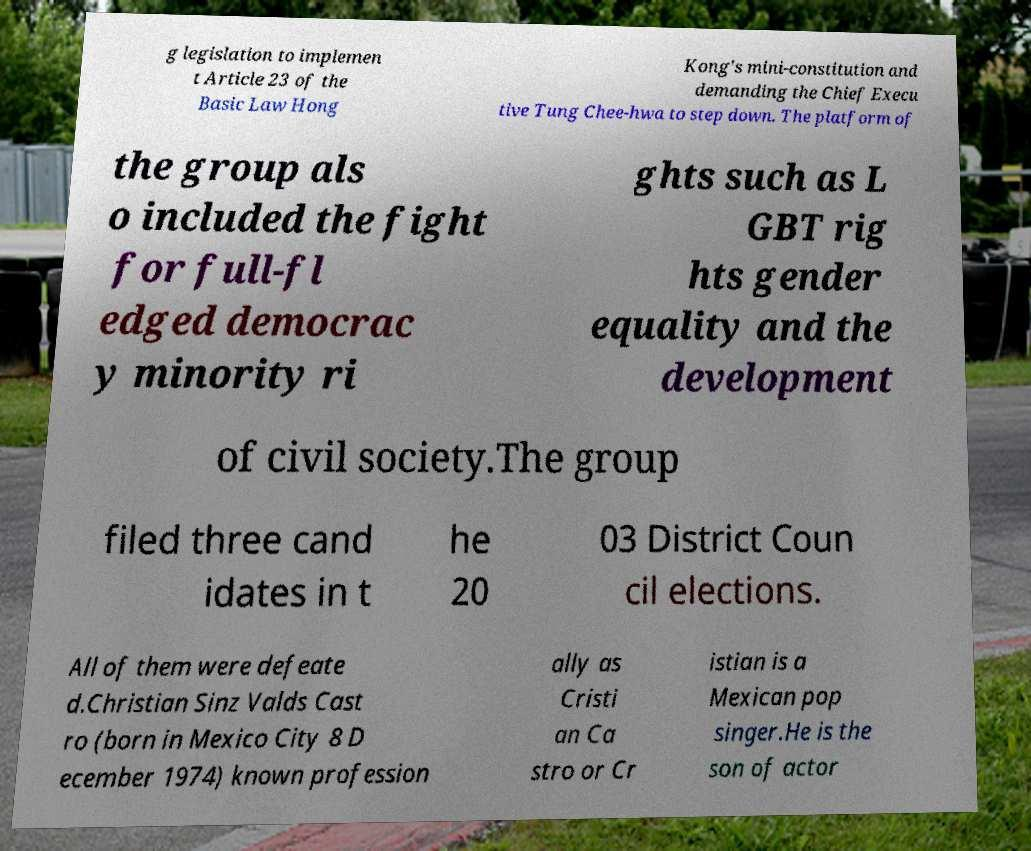For documentation purposes, I need the text within this image transcribed. Could you provide that? g legislation to implemen t Article 23 of the Basic Law Hong Kong's mini-constitution and demanding the Chief Execu tive Tung Chee-hwa to step down. The platform of the group als o included the fight for full-fl edged democrac y minority ri ghts such as L GBT rig hts gender equality and the development of civil society.The group filed three cand idates in t he 20 03 District Coun cil elections. All of them were defeate d.Christian Sinz Valds Cast ro (born in Mexico City 8 D ecember 1974) known profession ally as Cristi an Ca stro or Cr istian is a Mexican pop singer.He is the son of actor 